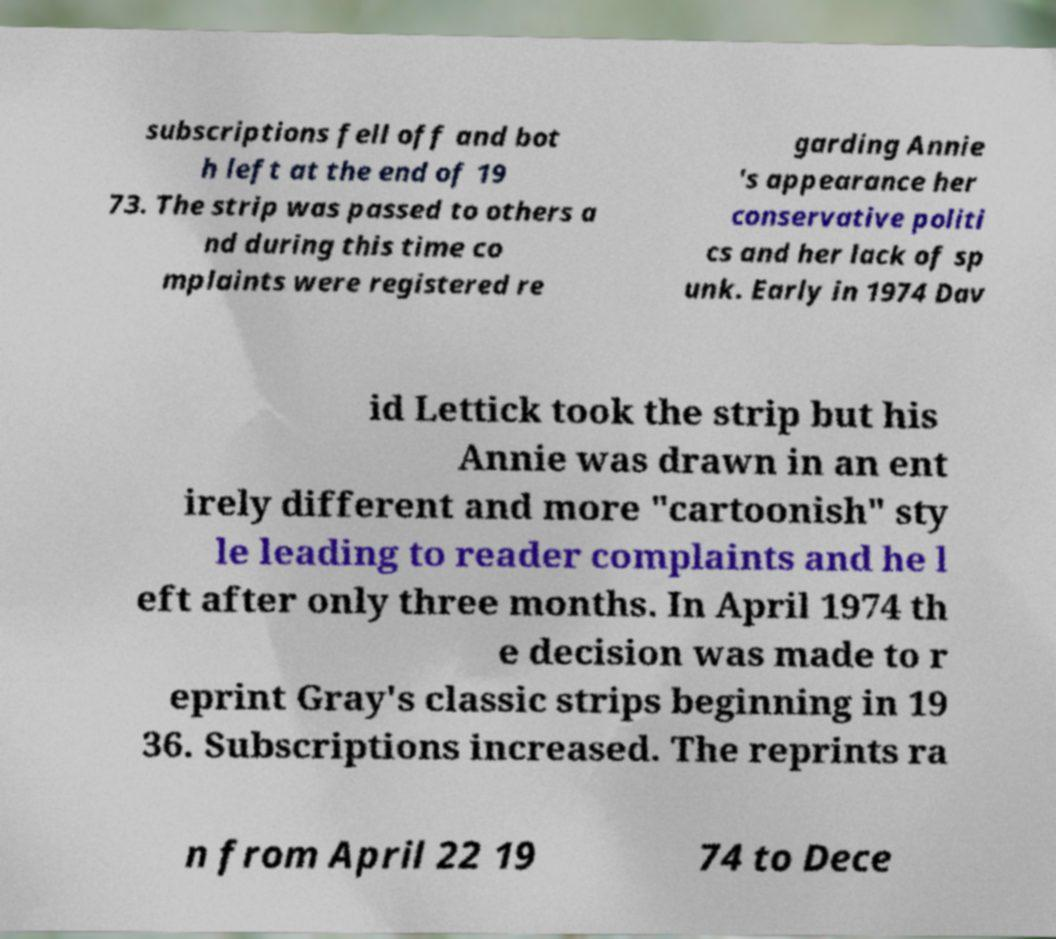I need the written content from this picture converted into text. Can you do that? subscriptions fell off and bot h left at the end of 19 73. The strip was passed to others a nd during this time co mplaints were registered re garding Annie 's appearance her conservative politi cs and her lack of sp unk. Early in 1974 Dav id Lettick took the strip but his Annie was drawn in an ent irely different and more "cartoonish" sty le leading to reader complaints and he l eft after only three months. In April 1974 th e decision was made to r eprint Gray's classic strips beginning in 19 36. Subscriptions increased. The reprints ra n from April 22 19 74 to Dece 